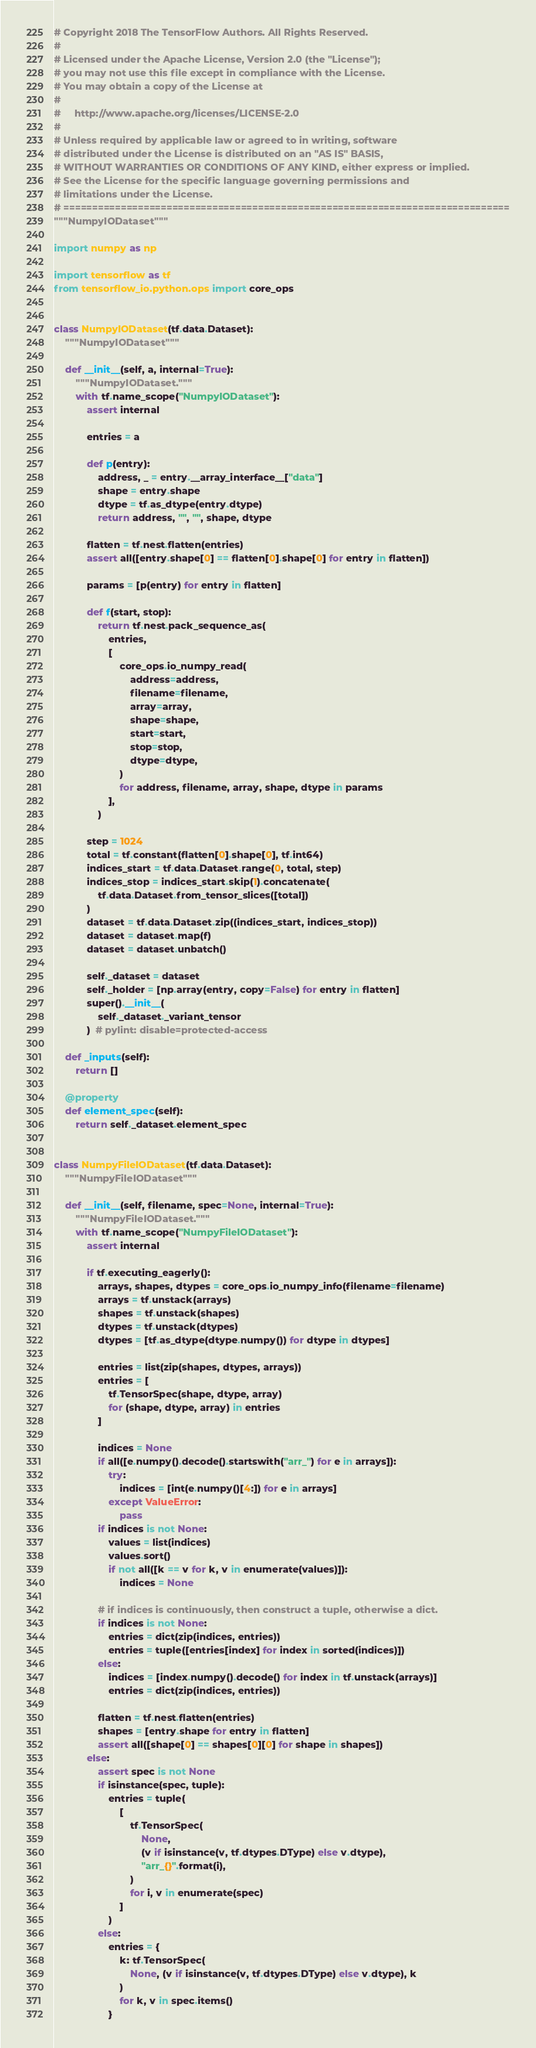Convert code to text. <code><loc_0><loc_0><loc_500><loc_500><_Python_># Copyright 2018 The TensorFlow Authors. All Rights Reserved.
#
# Licensed under the Apache License, Version 2.0 (the "License");
# you may not use this file except in compliance with the License.
# You may obtain a copy of the License at
#
#     http://www.apache.org/licenses/LICENSE-2.0
#
# Unless required by applicable law or agreed to in writing, software
# distributed under the License is distributed on an "AS IS" BASIS,
# WITHOUT WARRANTIES OR CONDITIONS OF ANY KIND, either express or implied.
# See the License for the specific language governing permissions and
# limitations under the License.
# ==============================================================================
"""NumpyIODataset"""

import numpy as np

import tensorflow as tf
from tensorflow_io.python.ops import core_ops


class NumpyIODataset(tf.data.Dataset):
    """NumpyIODataset"""

    def __init__(self, a, internal=True):
        """NumpyIODataset."""
        with tf.name_scope("NumpyIODataset"):
            assert internal

            entries = a

            def p(entry):
                address, _ = entry.__array_interface__["data"]
                shape = entry.shape
                dtype = tf.as_dtype(entry.dtype)
                return address, "", "", shape, dtype

            flatten = tf.nest.flatten(entries)
            assert all([entry.shape[0] == flatten[0].shape[0] for entry in flatten])

            params = [p(entry) for entry in flatten]

            def f(start, stop):
                return tf.nest.pack_sequence_as(
                    entries,
                    [
                        core_ops.io_numpy_read(
                            address=address,
                            filename=filename,
                            array=array,
                            shape=shape,
                            start=start,
                            stop=stop,
                            dtype=dtype,
                        )
                        for address, filename, array, shape, dtype in params
                    ],
                )

            step = 1024
            total = tf.constant(flatten[0].shape[0], tf.int64)
            indices_start = tf.data.Dataset.range(0, total, step)
            indices_stop = indices_start.skip(1).concatenate(
                tf.data.Dataset.from_tensor_slices([total])
            )
            dataset = tf.data.Dataset.zip((indices_start, indices_stop))
            dataset = dataset.map(f)
            dataset = dataset.unbatch()

            self._dataset = dataset
            self._holder = [np.array(entry, copy=False) for entry in flatten]
            super().__init__(
                self._dataset._variant_tensor
            )  # pylint: disable=protected-access

    def _inputs(self):
        return []

    @property
    def element_spec(self):
        return self._dataset.element_spec


class NumpyFileIODataset(tf.data.Dataset):
    """NumpyFileIODataset"""

    def __init__(self, filename, spec=None, internal=True):
        """NumpyFileIODataset."""
        with tf.name_scope("NumpyFileIODataset"):
            assert internal

            if tf.executing_eagerly():
                arrays, shapes, dtypes = core_ops.io_numpy_info(filename=filename)
                arrays = tf.unstack(arrays)
                shapes = tf.unstack(shapes)
                dtypes = tf.unstack(dtypes)
                dtypes = [tf.as_dtype(dtype.numpy()) for dtype in dtypes]

                entries = list(zip(shapes, dtypes, arrays))
                entries = [
                    tf.TensorSpec(shape, dtype, array)
                    for (shape, dtype, array) in entries
                ]

                indices = None
                if all([e.numpy().decode().startswith("arr_") for e in arrays]):
                    try:
                        indices = [int(e.numpy()[4:]) for e in arrays]
                    except ValueError:
                        pass
                if indices is not None:
                    values = list(indices)
                    values.sort()
                    if not all([k == v for k, v in enumerate(values)]):
                        indices = None

                # if indices is continuously, then construct a tuple, otherwise a dict.
                if indices is not None:
                    entries = dict(zip(indices, entries))
                    entries = tuple([entries[index] for index in sorted(indices)])
                else:
                    indices = [index.numpy().decode() for index in tf.unstack(arrays)]
                    entries = dict(zip(indices, entries))

                flatten = tf.nest.flatten(entries)
                shapes = [entry.shape for entry in flatten]
                assert all([shape[0] == shapes[0][0] for shape in shapes])
            else:
                assert spec is not None
                if isinstance(spec, tuple):
                    entries = tuple(
                        [
                            tf.TensorSpec(
                                None,
                                (v if isinstance(v, tf.dtypes.DType) else v.dtype),
                                "arr_{}".format(i),
                            )
                            for i, v in enumerate(spec)
                        ]
                    )
                else:
                    entries = {
                        k: tf.TensorSpec(
                            None, (v if isinstance(v, tf.dtypes.DType) else v.dtype), k
                        )
                        for k, v in spec.items()
                    }</code> 